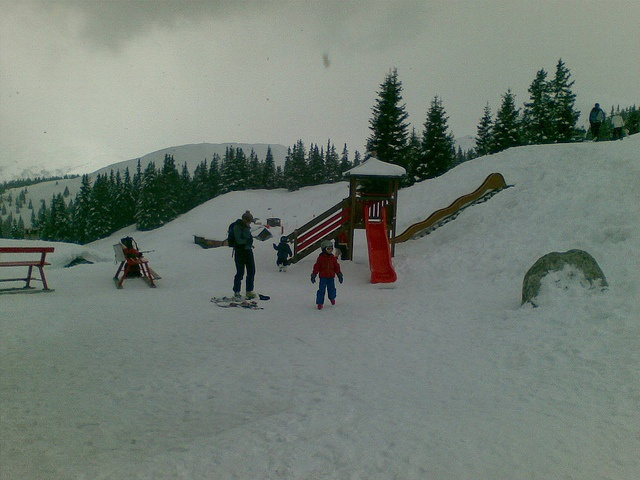Describe the objects in this image and their specific colors. I can see people in darkgray, black, gray, and purple tones, bench in darkgray, black, gray, and maroon tones, people in darkgray, black, maroon, gray, and navy tones, bench in darkgray, black, gray, and maroon tones, and people in darkgray, black, gray, and purple tones in this image. 